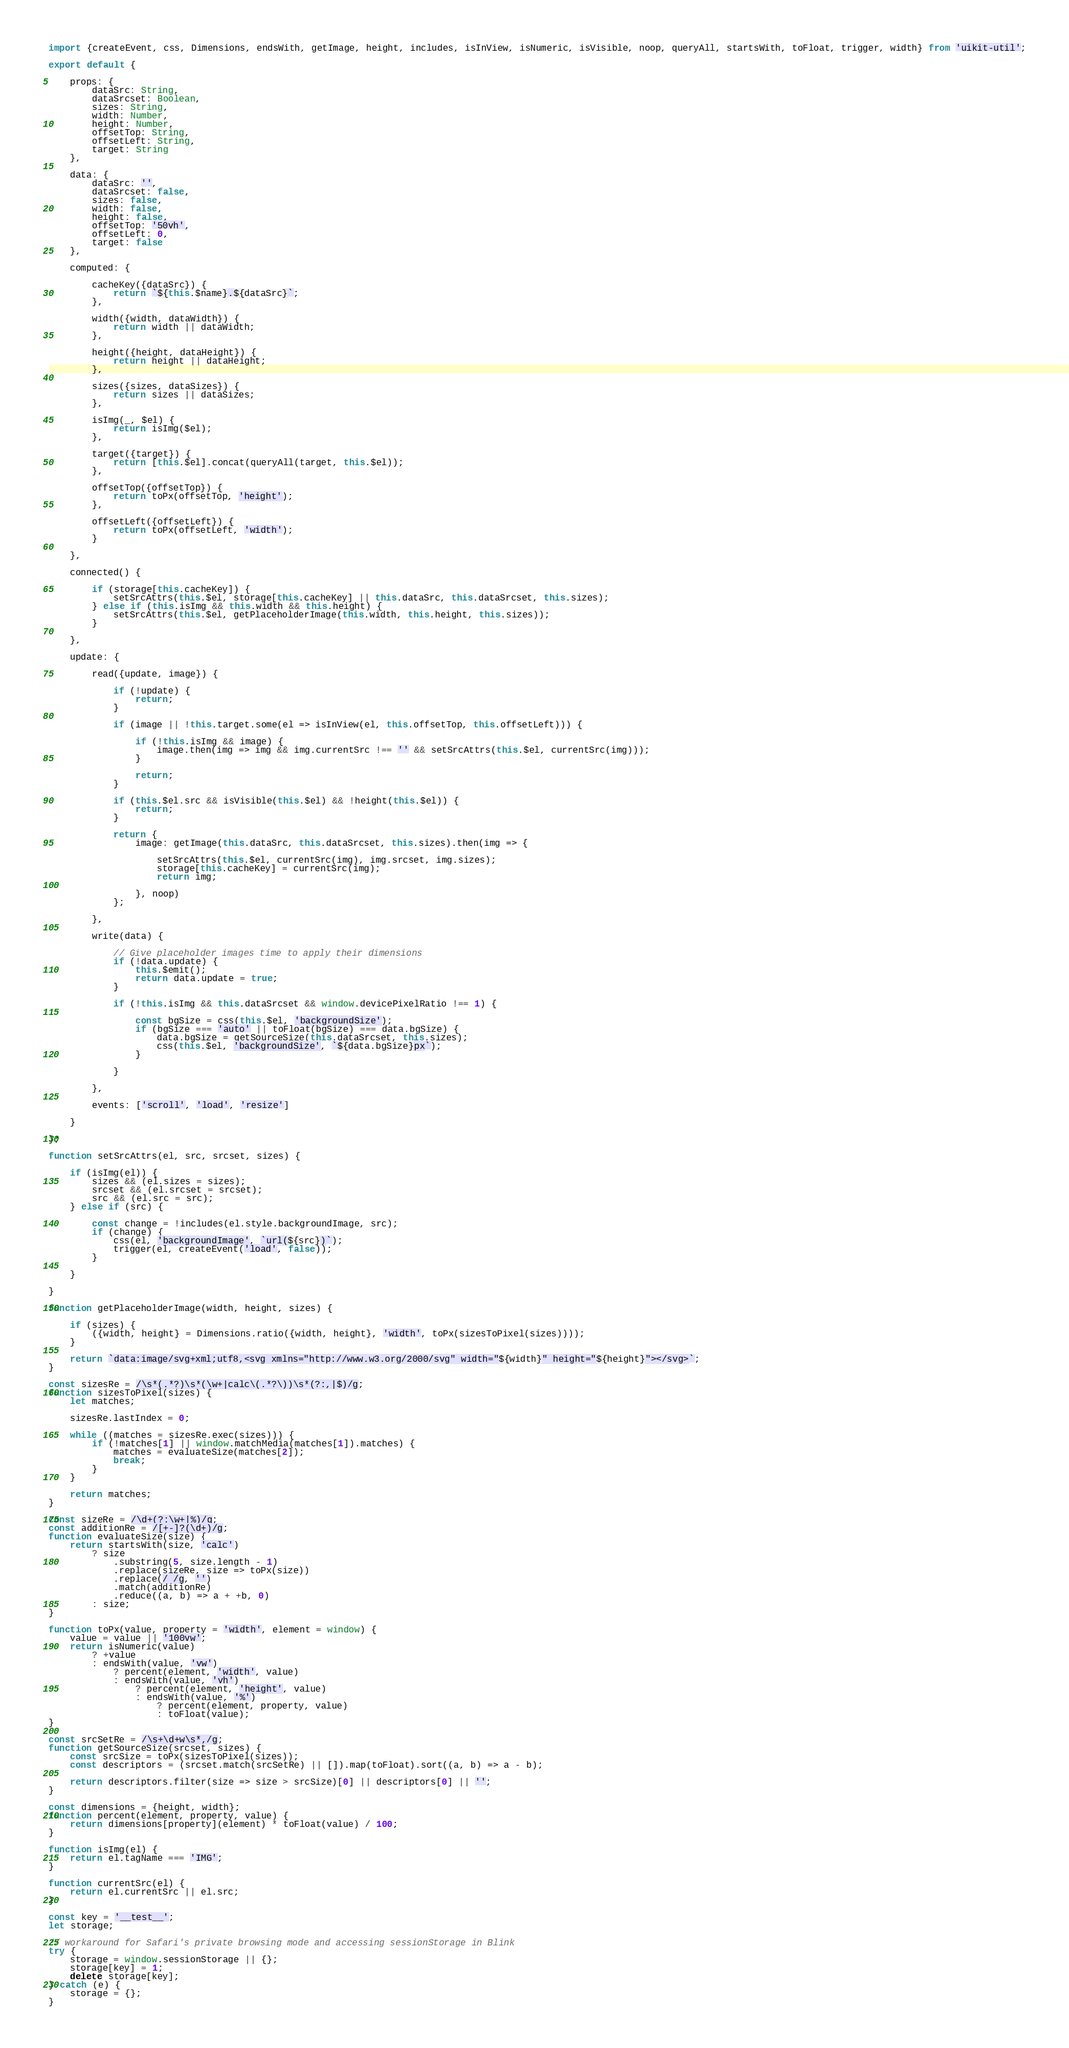Convert code to text. <code><loc_0><loc_0><loc_500><loc_500><_JavaScript_>import {createEvent, css, Dimensions, endsWith, getImage, height, includes, isInView, isNumeric, isVisible, noop, queryAll, startsWith, toFloat, trigger, width} from 'uikit-util';

export default {

    props: {
        dataSrc: String,
        dataSrcset: Boolean,
        sizes: String,
        width: Number,
        height: Number,
        offsetTop: String,
        offsetLeft: String,
        target: String
    },

    data: {
        dataSrc: '',
        dataSrcset: false,
        sizes: false,
        width: false,
        height: false,
        offsetTop: '50vh',
        offsetLeft: 0,
        target: false
    },

    computed: {

        cacheKey({dataSrc}) {
            return `${this.$name}.${dataSrc}`;
        },

        width({width, dataWidth}) {
            return width || dataWidth;
        },

        height({height, dataHeight}) {
            return height || dataHeight;
        },

        sizes({sizes, dataSizes}) {
            return sizes || dataSizes;
        },

        isImg(_, $el) {
            return isImg($el);
        },

        target({target}) {
            return [this.$el].concat(queryAll(target, this.$el));
        },

        offsetTop({offsetTop}) {
            return toPx(offsetTop, 'height');
        },

        offsetLeft({offsetLeft}) {
            return toPx(offsetLeft, 'width');
        }

    },

    connected() {

        if (storage[this.cacheKey]) {
            setSrcAttrs(this.$el, storage[this.cacheKey] || this.dataSrc, this.dataSrcset, this.sizes);
        } else if (this.isImg && this.width && this.height) {
            setSrcAttrs(this.$el, getPlaceholderImage(this.width, this.height, this.sizes));
        }

    },

    update: {

        read({update, image}) {

            if (!update) {
                return;
            }

            if (image || !this.target.some(el => isInView(el, this.offsetTop, this.offsetLeft))) {

                if (!this.isImg && image) {
                    image.then(img => img && img.currentSrc !== '' && setSrcAttrs(this.$el, currentSrc(img)));
                }

                return;
            }

            if (this.$el.src && isVisible(this.$el) && !height(this.$el)) {
                return;
            }

            return {
                image: getImage(this.dataSrc, this.dataSrcset, this.sizes).then(img => {

                    setSrcAttrs(this.$el, currentSrc(img), img.srcset, img.sizes);
                    storage[this.cacheKey] = currentSrc(img);
                    return img;

                }, noop)
            };

        },

        write(data) {

            // Give placeholder images time to apply their dimensions
            if (!data.update) {
                this.$emit();
                return data.update = true;
            }

            if (!this.isImg && this.dataSrcset && window.devicePixelRatio !== 1) {

                const bgSize = css(this.$el, 'backgroundSize');
                if (bgSize === 'auto' || toFloat(bgSize) === data.bgSize) {
                    data.bgSize = getSourceSize(this.dataSrcset, this.sizes);
                    css(this.$el, 'backgroundSize', `${data.bgSize}px`);
                }

            }

        },

        events: ['scroll', 'load', 'resize']

    }

};

function setSrcAttrs(el, src, srcset, sizes) {

    if (isImg(el)) {
        sizes && (el.sizes = sizes);
        srcset && (el.srcset = srcset);
        src && (el.src = src);
    } else if (src) {

        const change = !includes(el.style.backgroundImage, src);
        if (change) {
            css(el, 'backgroundImage', `url(${src})`);
            trigger(el, createEvent('load', false));
        }

    }

}

function getPlaceholderImage(width, height, sizes) {

    if (sizes) {
        ({width, height} = Dimensions.ratio({width, height}, 'width', toPx(sizesToPixel(sizes))));
    }

    return `data:image/svg+xml;utf8,<svg xmlns="http://www.w3.org/2000/svg" width="${width}" height="${height}"></svg>`;
}

const sizesRe = /\s*(.*?)\s*(\w+|calc\(.*?\))\s*(?:,|$)/g;
function sizesToPixel(sizes) {
    let matches;

    sizesRe.lastIndex = 0;

    while ((matches = sizesRe.exec(sizes))) {
        if (!matches[1] || window.matchMedia(matches[1]).matches) {
            matches = evaluateSize(matches[2]);
            break;
        }
    }

    return matches;
}

const sizeRe = /\d+(?:\w+|%)/g;
const additionRe = /[+-]?(\d+)/g;
function evaluateSize(size) {
    return startsWith(size, 'calc')
        ? size
            .substring(5, size.length - 1)
            .replace(sizeRe, size => toPx(size))
            .replace(/ /g, '')
            .match(additionRe)
            .reduce((a, b) => a + +b, 0)
        : size;
}

function toPx(value, property = 'width', element = window) {
    value = value || '100vw';
    return isNumeric(value)
        ? +value
        : endsWith(value, 'vw')
            ? percent(element, 'width', value)
            : endsWith(value, 'vh')
                ? percent(element, 'height', value)
                : endsWith(value, '%')
                    ? percent(element, property, value)
                    : toFloat(value);
}

const srcSetRe = /\s+\d+w\s*,/g;
function getSourceSize(srcset, sizes) {
    const srcSize = toPx(sizesToPixel(sizes));
    const descriptors = (srcset.match(srcSetRe) || []).map(toFloat).sort((a, b) => a - b);

    return descriptors.filter(size => size > srcSize)[0] || descriptors[0] || '';
}

const dimensions = {height, width};
function percent(element, property, value) {
    return dimensions[property](element) * toFloat(value) / 100;
}

function isImg(el) {
    return el.tagName === 'IMG';
}

function currentSrc(el) {
    return el.currentSrc || el.src;
}

const key = '__test__';
let storage;

// workaround for Safari's private browsing mode and accessing sessionStorage in Blink
try {
    storage = window.sessionStorage || {};
    storage[key] = 1;
    delete storage[key];
} catch (e) {
    storage = {};
}
</code> 